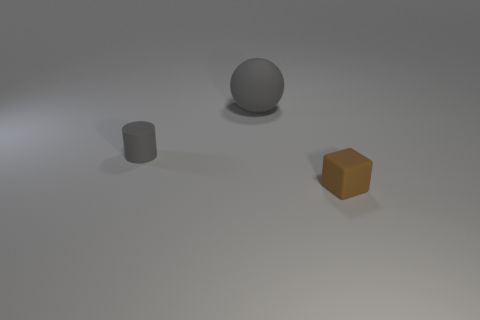There is a large sphere that is the same color as the small matte cylinder; what material is it?
Offer a very short reply. Rubber. There is a gray rubber thing in front of the matte ball; is its size the same as the large sphere?
Your answer should be very brief. No. There is a small rubber thing that is in front of the gray thing in front of the matte sphere; are there any tiny gray rubber objects to the right of it?
Keep it short and to the point. No. What number of rubber objects are either tiny yellow cylinders or large objects?
Provide a succinct answer. 1. How many other things are the same shape as the large object?
Your response must be concise. 0. Is the number of gray matte cylinders greater than the number of things?
Provide a succinct answer. No. There is a cube that is in front of the rubber thing that is behind the small thing left of the gray matte ball; how big is it?
Your answer should be compact. Small. There is a rubber object that is behind the small cylinder; what size is it?
Your response must be concise. Large. What number of things are either large gray balls or objects that are on the left side of the tiny brown matte thing?
Provide a succinct answer. 2. How many other objects are there of the same size as the brown matte object?
Ensure brevity in your answer.  1. 